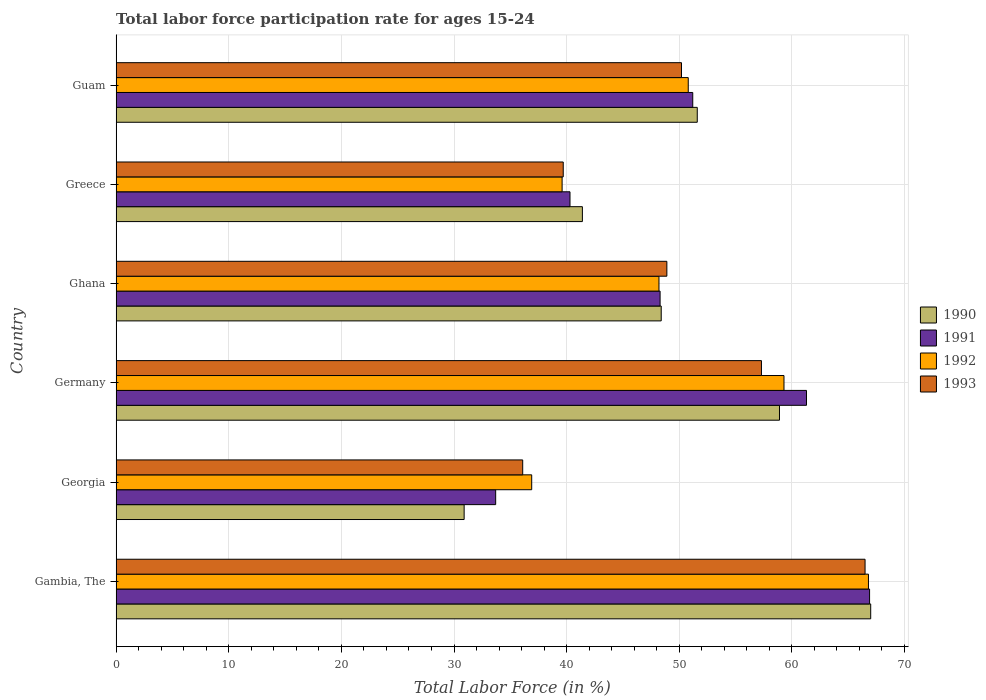How many groups of bars are there?
Offer a terse response. 6. How many bars are there on the 3rd tick from the top?
Your answer should be compact. 4. What is the label of the 2nd group of bars from the top?
Provide a succinct answer. Greece. What is the labor force participation rate in 1992 in Guam?
Your answer should be compact. 50.8. Across all countries, what is the maximum labor force participation rate in 1993?
Offer a terse response. 66.5. Across all countries, what is the minimum labor force participation rate in 1991?
Provide a short and direct response. 33.7. In which country was the labor force participation rate in 1991 maximum?
Provide a short and direct response. Gambia, The. In which country was the labor force participation rate in 1990 minimum?
Offer a terse response. Georgia. What is the total labor force participation rate in 1992 in the graph?
Offer a terse response. 301.6. What is the difference between the labor force participation rate in 1991 in Georgia and that in Germany?
Give a very brief answer. -27.6. What is the difference between the labor force participation rate in 1991 in Ghana and the labor force participation rate in 1993 in Guam?
Offer a very short reply. -1.9. What is the average labor force participation rate in 1991 per country?
Offer a very short reply. 50.28. What is the difference between the labor force participation rate in 1992 and labor force participation rate in 1990 in Guam?
Offer a very short reply. -0.8. What is the ratio of the labor force participation rate in 1991 in Georgia to that in Greece?
Offer a terse response. 0.84. Is the difference between the labor force participation rate in 1992 in Georgia and Greece greater than the difference between the labor force participation rate in 1990 in Georgia and Greece?
Keep it short and to the point. Yes. What is the difference between the highest and the second highest labor force participation rate in 1992?
Make the answer very short. 7.5. What is the difference between the highest and the lowest labor force participation rate in 1992?
Ensure brevity in your answer.  29.9. Is the sum of the labor force participation rate in 1991 in Georgia and Germany greater than the maximum labor force participation rate in 1992 across all countries?
Your response must be concise. Yes. Is it the case that in every country, the sum of the labor force participation rate in 1990 and labor force participation rate in 1992 is greater than the labor force participation rate in 1993?
Make the answer very short. Yes. Are all the bars in the graph horizontal?
Offer a very short reply. Yes. What is the difference between two consecutive major ticks on the X-axis?
Your answer should be very brief. 10. Are the values on the major ticks of X-axis written in scientific E-notation?
Ensure brevity in your answer.  No. How many legend labels are there?
Your answer should be very brief. 4. What is the title of the graph?
Provide a succinct answer. Total labor force participation rate for ages 15-24. What is the label or title of the X-axis?
Provide a succinct answer. Total Labor Force (in %). What is the label or title of the Y-axis?
Give a very brief answer. Country. What is the Total Labor Force (in %) of 1991 in Gambia, The?
Your response must be concise. 66.9. What is the Total Labor Force (in %) in 1992 in Gambia, The?
Provide a short and direct response. 66.8. What is the Total Labor Force (in %) in 1993 in Gambia, The?
Provide a succinct answer. 66.5. What is the Total Labor Force (in %) in 1990 in Georgia?
Your answer should be compact. 30.9. What is the Total Labor Force (in %) of 1991 in Georgia?
Keep it short and to the point. 33.7. What is the Total Labor Force (in %) of 1992 in Georgia?
Provide a succinct answer. 36.9. What is the Total Labor Force (in %) in 1993 in Georgia?
Ensure brevity in your answer.  36.1. What is the Total Labor Force (in %) in 1990 in Germany?
Ensure brevity in your answer.  58.9. What is the Total Labor Force (in %) in 1991 in Germany?
Ensure brevity in your answer.  61.3. What is the Total Labor Force (in %) of 1992 in Germany?
Your response must be concise. 59.3. What is the Total Labor Force (in %) of 1993 in Germany?
Your answer should be very brief. 57.3. What is the Total Labor Force (in %) in 1990 in Ghana?
Offer a terse response. 48.4. What is the Total Labor Force (in %) of 1991 in Ghana?
Offer a very short reply. 48.3. What is the Total Labor Force (in %) in 1992 in Ghana?
Make the answer very short. 48.2. What is the Total Labor Force (in %) of 1993 in Ghana?
Keep it short and to the point. 48.9. What is the Total Labor Force (in %) of 1990 in Greece?
Your answer should be very brief. 41.4. What is the Total Labor Force (in %) of 1991 in Greece?
Your answer should be compact. 40.3. What is the Total Labor Force (in %) of 1992 in Greece?
Keep it short and to the point. 39.6. What is the Total Labor Force (in %) of 1993 in Greece?
Offer a very short reply. 39.7. What is the Total Labor Force (in %) in 1990 in Guam?
Make the answer very short. 51.6. What is the Total Labor Force (in %) of 1991 in Guam?
Give a very brief answer. 51.2. What is the Total Labor Force (in %) in 1992 in Guam?
Offer a terse response. 50.8. What is the Total Labor Force (in %) in 1993 in Guam?
Provide a short and direct response. 50.2. Across all countries, what is the maximum Total Labor Force (in %) of 1990?
Offer a terse response. 67. Across all countries, what is the maximum Total Labor Force (in %) of 1991?
Offer a very short reply. 66.9. Across all countries, what is the maximum Total Labor Force (in %) of 1992?
Your answer should be very brief. 66.8. Across all countries, what is the maximum Total Labor Force (in %) of 1993?
Ensure brevity in your answer.  66.5. Across all countries, what is the minimum Total Labor Force (in %) of 1990?
Your answer should be compact. 30.9. Across all countries, what is the minimum Total Labor Force (in %) of 1991?
Provide a succinct answer. 33.7. Across all countries, what is the minimum Total Labor Force (in %) in 1992?
Make the answer very short. 36.9. Across all countries, what is the minimum Total Labor Force (in %) in 1993?
Your answer should be compact. 36.1. What is the total Total Labor Force (in %) in 1990 in the graph?
Provide a short and direct response. 298.2. What is the total Total Labor Force (in %) in 1991 in the graph?
Offer a very short reply. 301.7. What is the total Total Labor Force (in %) of 1992 in the graph?
Make the answer very short. 301.6. What is the total Total Labor Force (in %) in 1993 in the graph?
Your answer should be compact. 298.7. What is the difference between the Total Labor Force (in %) in 1990 in Gambia, The and that in Georgia?
Make the answer very short. 36.1. What is the difference between the Total Labor Force (in %) of 1991 in Gambia, The and that in Georgia?
Your answer should be compact. 33.2. What is the difference between the Total Labor Force (in %) of 1992 in Gambia, The and that in Georgia?
Your answer should be compact. 29.9. What is the difference between the Total Labor Force (in %) in 1993 in Gambia, The and that in Georgia?
Give a very brief answer. 30.4. What is the difference between the Total Labor Force (in %) of 1990 in Gambia, The and that in Ghana?
Ensure brevity in your answer.  18.6. What is the difference between the Total Labor Force (in %) in 1991 in Gambia, The and that in Ghana?
Ensure brevity in your answer.  18.6. What is the difference between the Total Labor Force (in %) in 1993 in Gambia, The and that in Ghana?
Offer a terse response. 17.6. What is the difference between the Total Labor Force (in %) in 1990 in Gambia, The and that in Greece?
Make the answer very short. 25.6. What is the difference between the Total Labor Force (in %) of 1991 in Gambia, The and that in Greece?
Ensure brevity in your answer.  26.6. What is the difference between the Total Labor Force (in %) in 1992 in Gambia, The and that in Greece?
Make the answer very short. 27.2. What is the difference between the Total Labor Force (in %) in 1993 in Gambia, The and that in Greece?
Offer a very short reply. 26.8. What is the difference between the Total Labor Force (in %) of 1992 in Gambia, The and that in Guam?
Your answer should be very brief. 16. What is the difference between the Total Labor Force (in %) in 1993 in Gambia, The and that in Guam?
Make the answer very short. 16.3. What is the difference between the Total Labor Force (in %) of 1991 in Georgia and that in Germany?
Give a very brief answer. -27.6. What is the difference between the Total Labor Force (in %) in 1992 in Georgia and that in Germany?
Ensure brevity in your answer.  -22.4. What is the difference between the Total Labor Force (in %) in 1993 in Georgia and that in Germany?
Your answer should be compact. -21.2. What is the difference between the Total Labor Force (in %) of 1990 in Georgia and that in Ghana?
Offer a terse response. -17.5. What is the difference between the Total Labor Force (in %) of 1991 in Georgia and that in Ghana?
Keep it short and to the point. -14.6. What is the difference between the Total Labor Force (in %) in 1993 in Georgia and that in Ghana?
Your answer should be very brief. -12.8. What is the difference between the Total Labor Force (in %) in 1990 in Georgia and that in Guam?
Your answer should be very brief. -20.7. What is the difference between the Total Labor Force (in %) of 1991 in Georgia and that in Guam?
Provide a succinct answer. -17.5. What is the difference between the Total Labor Force (in %) in 1993 in Georgia and that in Guam?
Give a very brief answer. -14.1. What is the difference between the Total Labor Force (in %) in 1990 in Germany and that in Ghana?
Your answer should be very brief. 10.5. What is the difference between the Total Labor Force (in %) of 1991 in Germany and that in Ghana?
Keep it short and to the point. 13. What is the difference between the Total Labor Force (in %) in 1993 in Germany and that in Ghana?
Ensure brevity in your answer.  8.4. What is the difference between the Total Labor Force (in %) of 1993 in Germany and that in Greece?
Give a very brief answer. 17.6. What is the difference between the Total Labor Force (in %) in 1990 in Germany and that in Guam?
Ensure brevity in your answer.  7.3. What is the difference between the Total Labor Force (in %) in 1991 in Germany and that in Guam?
Your answer should be compact. 10.1. What is the difference between the Total Labor Force (in %) of 1992 in Germany and that in Guam?
Provide a succinct answer. 8.5. What is the difference between the Total Labor Force (in %) in 1990 in Ghana and that in Greece?
Offer a very short reply. 7. What is the difference between the Total Labor Force (in %) of 1990 in Ghana and that in Guam?
Offer a terse response. -3.2. What is the difference between the Total Labor Force (in %) of 1991 in Ghana and that in Guam?
Your answer should be very brief. -2.9. What is the difference between the Total Labor Force (in %) of 1992 in Ghana and that in Guam?
Your answer should be compact. -2.6. What is the difference between the Total Labor Force (in %) of 1990 in Greece and that in Guam?
Provide a short and direct response. -10.2. What is the difference between the Total Labor Force (in %) in 1991 in Greece and that in Guam?
Give a very brief answer. -10.9. What is the difference between the Total Labor Force (in %) of 1992 in Greece and that in Guam?
Give a very brief answer. -11.2. What is the difference between the Total Labor Force (in %) of 1990 in Gambia, The and the Total Labor Force (in %) of 1991 in Georgia?
Offer a terse response. 33.3. What is the difference between the Total Labor Force (in %) of 1990 in Gambia, The and the Total Labor Force (in %) of 1992 in Georgia?
Provide a short and direct response. 30.1. What is the difference between the Total Labor Force (in %) in 1990 in Gambia, The and the Total Labor Force (in %) in 1993 in Georgia?
Keep it short and to the point. 30.9. What is the difference between the Total Labor Force (in %) of 1991 in Gambia, The and the Total Labor Force (in %) of 1992 in Georgia?
Your answer should be very brief. 30. What is the difference between the Total Labor Force (in %) of 1991 in Gambia, The and the Total Labor Force (in %) of 1993 in Georgia?
Offer a terse response. 30.8. What is the difference between the Total Labor Force (in %) of 1992 in Gambia, The and the Total Labor Force (in %) of 1993 in Georgia?
Your answer should be very brief. 30.7. What is the difference between the Total Labor Force (in %) in 1990 in Gambia, The and the Total Labor Force (in %) in 1991 in Germany?
Provide a succinct answer. 5.7. What is the difference between the Total Labor Force (in %) of 1991 in Gambia, The and the Total Labor Force (in %) of 1993 in Ghana?
Provide a succinct answer. 18. What is the difference between the Total Labor Force (in %) of 1990 in Gambia, The and the Total Labor Force (in %) of 1991 in Greece?
Make the answer very short. 26.7. What is the difference between the Total Labor Force (in %) of 1990 in Gambia, The and the Total Labor Force (in %) of 1992 in Greece?
Keep it short and to the point. 27.4. What is the difference between the Total Labor Force (in %) of 1990 in Gambia, The and the Total Labor Force (in %) of 1993 in Greece?
Keep it short and to the point. 27.3. What is the difference between the Total Labor Force (in %) in 1991 in Gambia, The and the Total Labor Force (in %) in 1992 in Greece?
Give a very brief answer. 27.3. What is the difference between the Total Labor Force (in %) in 1991 in Gambia, The and the Total Labor Force (in %) in 1993 in Greece?
Provide a short and direct response. 27.2. What is the difference between the Total Labor Force (in %) of 1992 in Gambia, The and the Total Labor Force (in %) of 1993 in Greece?
Offer a terse response. 27.1. What is the difference between the Total Labor Force (in %) in 1990 in Gambia, The and the Total Labor Force (in %) in 1991 in Guam?
Provide a succinct answer. 15.8. What is the difference between the Total Labor Force (in %) of 1991 in Gambia, The and the Total Labor Force (in %) of 1993 in Guam?
Provide a succinct answer. 16.7. What is the difference between the Total Labor Force (in %) of 1990 in Georgia and the Total Labor Force (in %) of 1991 in Germany?
Offer a terse response. -30.4. What is the difference between the Total Labor Force (in %) in 1990 in Georgia and the Total Labor Force (in %) in 1992 in Germany?
Your answer should be compact. -28.4. What is the difference between the Total Labor Force (in %) in 1990 in Georgia and the Total Labor Force (in %) in 1993 in Germany?
Your answer should be very brief. -26.4. What is the difference between the Total Labor Force (in %) in 1991 in Georgia and the Total Labor Force (in %) in 1992 in Germany?
Make the answer very short. -25.6. What is the difference between the Total Labor Force (in %) of 1991 in Georgia and the Total Labor Force (in %) of 1993 in Germany?
Provide a short and direct response. -23.6. What is the difference between the Total Labor Force (in %) of 1992 in Georgia and the Total Labor Force (in %) of 1993 in Germany?
Give a very brief answer. -20.4. What is the difference between the Total Labor Force (in %) in 1990 in Georgia and the Total Labor Force (in %) in 1991 in Ghana?
Provide a succinct answer. -17.4. What is the difference between the Total Labor Force (in %) in 1990 in Georgia and the Total Labor Force (in %) in 1992 in Ghana?
Your answer should be compact. -17.3. What is the difference between the Total Labor Force (in %) of 1991 in Georgia and the Total Labor Force (in %) of 1992 in Ghana?
Make the answer very short. -14.5. What is the difference between the Total Labor Force (in %) of 1991 in Georgia and the Total Labor Force (in %) of 1993 in Ghana?
Your answer should be compact. -15.2. What is the difference between the Total Labor Force (in %) in 1990 in Georgia and the Total Labor Force (in %) in 1991 in Greece?
Offer a terse response. -9.4. What is the difference between the Total Labor Force (in %) of 1990 in Georgia and the Total Labor Force (in %) of 1993 in Greece?
Make the answer very short. -8.8. What is the difference between the Total Labor Force (in %) of 1991 in Georgia and the Total Labor Force (in %) of 1992 in Greece?
Ensure brevity in your answer.  -5.9. What is the difference between the Total Labor Force (in %) of 1991 in Georgia and the Total Labor Force (in %) of 1993 in Greece?
Give a very brief answer. -6. What is the difference between the Total Labor Force (in %) in 1990 in Georgia and the Total Labor Force (in %) in 1991 in Guam?
Keep it short and to the point. -20.3. What is the difference between the Total Labor Force (in %) in 1990 in Georgia and the Total Labor Force (in %) in 1992 in Guam?
Your answer should be compact. -19.9. What is the difference between the Total Labor Force (in %) in 1990 in Georgia and the Total Labor Force (in %) in 1993 in Guam?
Your answer should be compact. -19.3. What is the difference between the Total Labor Force (in %) in 1991 in Georgia and the Total Labor Force (in %) in 1992 in Guam?
Offer a terse response. -17.1. What is the difference between the Total Labor Force (in %) of 1991 in Georgia and the Total Labor Force (in %) of 1993 in Guam?
Offer a very short reply. -16.5. What is the difference between the Total Labor Force (in %) in 1992 in Georgia and the Total Labor Force (in %) in 1993 in Guam?
Keep it short and to the point. -13.3. What is the difference between the Total Labor Force (in %) in 1990 in Germany and the Total Labor Force (in %) in 1991 in Ghana?
Provide a short and direct response. 10.6. What is the difference between the Total Labor Force (in %) in 1990 in Germany and the Total Labor Force (in %) in 1993 in Ghana?
Provide a succinct answer. 10. What is the difference between the Total Labor Force (in %) of 1991 in Germany and the Total Labor Force (in %) of 1993 in Ghana?
Your answer should be compact. 12.4. What is the difference between the Total Labor Force (in %) in 1992 in Germany and the Total Labor Force (in %) in 1993 in Ghana?
Your response must be concise. 10.4. What is the difference between the Total Labor Force (in %) of 1990 in Germany and the Total Labor Force (in %) of 1992 in Greece?
Make the answer very short. 19.3. What is the difference between the Total Labor Force (in %) in 1991 in Germany and the Total Labor Force (in %) in 1992 in Greece?
Keep it short and to the point. 21.7. What is the difference between the Total Labor Force (in %) in 1991 in Germany and the Total Labor Force (in %) in 1993 in Greece?
Offer a very short reply. 21.6. What is the difference between the Total Labor Force (in %) in 1992 in Germany and the Total Labor Force (in %) in 1993 in Greece?
Provide a short and direct response. 19.6. What is the difference between the Total Labor Force (in %) in 1990 in Germany and the Total Labor Force (in %) in 1992 in Guam?
Provide a succinct answer. 8.1. What is the difference between the Total Labor Force (in %) of 1990 in Germany and the Total Labor Force (in %) of 1993 in Guam?
Your answer should be very brief. 8.7. What is the difference between the Total Labor Force (in %) of 1992 in Germany and the Total Labor Force (in %) of 1993 in Guam?
Make the answer very short. 9.1. What is the difference between the Total Labor Force (in %) of 1990 in Ghana and the Total Labor Force (in %) of 1992 in Greece?
Offer a very short reply. 8.8. What is the difference between the Total Labor Force (in %) of 1991 in Ghana and the Total Labor Force (in %) of 1993 in Greece?
Ensure brevity in your answer.  8.6. What is the difference between the Total Labor Force (in %) in 1992 in Ghana and the Total Labor Force (in %) in 1993 in Greece?
Make the answer very short. 8.5. What is the difference between the Total Labor Force (in %) of 1990 in Ghana and the Total Labor Force (in %) of 1991 in Guam?
Ensure brevity in your answer.  -2.8. What is the difference between the Total Labor Force (in %) in 1990 in Greece and the Total Labor Force (in %) in 1992 in Guam?
Offer a terse response. -9.4. What is the difference between the Total Labor Force (in %) in 1990 in Greece and the Total Labor Force (in %) in 1993 in Guam?
Keep it short and to the point. -8.8. What is the difference between the Total Labor Force (in %) in 1991 in Greece and the Total Labor Force (in %) in 1992 in Guam?
Provide a succinct answer. -10.5. What is the average Total Labor Force (in %) in 1990 per country?
Offer a very short reply. 49.7. What is the average Total Labor Force (in %) of 1991 per country?
Your answer should be very brief. 50.28. What is the average Total Labor Force (in %) in 1992 per country?
Offer a terse response. 50.27. What is the average Total Labor Force (in %) of 1993 per country?
Your answer should be very brief. 49.78. What is the difference between the Total Labor Force (in %) of 1990 and Total Labor Force (in %) of 1991 in Gambia, The?
Give a very brief answer. 0.1. What is the difference between the Total Labor Force (in %) in 1990 and Total Labor Force (in %) in 1993 in Gambia, The?
Your answer should be very brief. 0.5. What is the difference between the Total Labor Force (in %) in 1991 and Total Labor Force (in %) in 1993 in Gambia, The?
Offer a terse response. 0.4. What is the difference between the Total Labor Force (in %) of 1990 and Total Labor Force (in %) of 1993 in Georgia?
Provide a short and direct response. -5.2. What is the difference between the Total Labor Force (in %) of 1991 and Total Labor Force (in %) of 1992 in Georgia?
Provide a short and direct response. -3.2. What is the difference between the Total Labor Force (in %) in 1991 and Total Labor Force (in %) in 1993 in Georgia?
Keep it short and to the point. -2.4. What is the difference between the Total Labor Force (in %) of 1992 and Total Labor Force (in %) of 1993 in Georgia?
Keep it short and to the point. 0.8. What is the difference between the Total Labor Force (in %) in 1991 and Total Labor Force (in %) in 1992 in Germany?
Offer a very short reply. 2. What is the difference between the Total Labor Force (in %) in 1992 and Total Labor Force (in %) in 1993 in Ghana?
Your response must be concise. -0.7. What is the difference between the Total Labor Force (in %) in 1990 and Total Labor Force (in %) in 1991 in Greece?
Your answer should be compact. 1.1. What is the difference between the Total Labor Force (in %) in 1990 and Total Labor Force (in %) in 1993 in Greece?
Make the answer very short. 1.7. What is the difference between the Total Labor Force (in %) of 1991 and Total Labor Force (in %) of 1992 in Greece?
Your response must be concise. 0.7. What is the difference between the Total Labor Force (in %) in 1990 and Total Labor Force (in %) in 1991 in Guam?
Your response must be concise. 0.4. What is the difference between the Total Labor Force (in %) in 1990 and Total Labor Force (in %) in 1992 in Guam?
Keep it short and to the point. 0.8. What is the difference between the Total Labor Force (in %) of 1990 and Total Labor Force (in %) of 1993 in Guam?
Provide a succinct answer. 1.4. What is the ratio of the Total Labor Force (in %) in 1990 in Gambia, The to that in Georgia?
Your answer should be compact. 2.17. What is the ratio of the Total Labor Force (in %) in 1991 in Gambia, The to that in Georgia?
Offer a very short reply. 1.99. What is the ratio of the Total Labor Force (in %) of 1992 in Gambia, The to that in Georgia?
Offer a very short reply. 1.81. What is the ratio of the Total Labor Force (in %) of 1993 in Gambia, The to that in Georgia?
Make the answer very short. 1.84. What is the ratio of the Total Labor Force (in %) of 1990 in Gambia, The to that in Germany?
Provide a short and direct response. 1.14. What is the ratio of the Total Labor Force (in %) in 1991 in Gambia, The to that in Germany?
Your answer should be compact. 1.09. What is the ratio of the Total Labor Force (in %) in 1992 in Gambia, The to that in Germany?
Your answer should be very brief. 1.13. What is the ratio of the Total Labor Force (in %) of 1993 in Gambia, The to that in Germany?
Give a very brief answer. 1.16. What is the ratio of the Total Labor Force (in %) of 1990 in Gambia, The to that in Ghana?
Ensure brevity in your answer.  1.38. What is the ratio of the Total Labor Force (in %) of 1991 in Gambia, The to that in Ghana?
Offer a terse response. 1.39. What is the ratio of the Total Labor Force (in %) in 1992 in Gambia, The to that in Ghana?
Provide a succinct answer. 1.39. What is the ratio of the Total Labor Force (in %) in 1993 in Gambia, The to that in Ghana?
Your answer should be very brief. 1.36. What is the ratio of the Total Labor Force (in %) in 1990 in Gambia, The to that in Greece?
Provide a succinct answer. 1.62. What is the ratio of the Total Labor Force (in %) of 1991 in Gambia, The to that in Greece?
Your answer should be compact. 1.66. What is the ratio of the Total Labor Force (in %) in 1992 in Gambia, The to that in Greece?
Offer a terse response. 1.69. What is the ratio of the Total Labor Force (in %) in 1993 in Gambia, The to that in Greece?
Keep it short and to the point. 1.68. What is the ratio of the Total Labor Force (in %) of 1990 in Gambia, The to that in Guam?
Keep it short and to the point. 1.3. What is the ratio of the Total Labor Force (in %) in 1991 in Gambia, The to that in Guam?
Provide a succinct answer. 1.31. What is the ratio of the Total Labor Force (in %) of 1992 in Gambia, The to that in Guam?
Provide a succinct answer. 1.31. What is the ratio of the Total Labor Force (in %) of 1993 in Gambia, The to that in Guam?
Provide a short and direct response. 1.32. What is the ratio of the Total Labor Force (in %) in 1990 in Georgia to that in Germany?
Offer a very short reply. 0.52. What is the ratio of the Total Labor Force (in %) of 1991 in Georgia to that in Germany?
Provide a succinct answer. 0.55. What is the ratio of the Total Labor Force (in %) in 1992 in Georgia to that in Germany?
Provide a short and direct response. 0.62. What is the ratio of the Total Labor Force (in %) in 1993 in Georgia to that in Germany?
Provide a short and direct response. 0.63. What is the ratio of the Total Labor Force (in %) in 1990 in Georgia to that in Ghana?
Keep it short and to the point. 0.64. What is the ratio of the Total Labor Force (in %) in 1991 in Georgia to that in Ghana?
Offer a terse response. 0.7. What is the ratio of the Total Labor Force (in %) in 1992 in Georgia to that in Ghana?
Provide a succinct answer. 0.77. What is the ratio of the Total Labor Force (in %) of 1993 in Georgia to that in Ghana?
Ensure brevity in your answer.  0.74. What is the ratio of the Total Labor Force (in %) in 1990 in Georgia to that in Greece?
Provide a short and direct response. 0.75. What is the ratio of the Total Labor Force (in %) in 1991 in Georgia to that in Greece?
Offer a terse response. 0.84. What is the ratio of the Total Labor Force (in %) of 1992 in Georgia to that in Greece?
Your answer should be very brief. 0.93. What is the ratio of the Total Labor Force (in %) of 1993 in Georgia to that in Greece?
Make the answer very short. 0.91. What is the ratio of the Total Labor Force (in %) in 1990 in Georgia to that in Guam?
Keep it short and to the point. 0.6. What is the ratio of the Total Labor Force (in %) in 1991 in Georgia to that in Guam?
Ensure brevity in your answer.  0.66. What is the ratio of the Total Labor Force (in %) of 1992 in Georgia to that in Guam?
Provide a succinct answer. 0.73. What is the ratio of the Total Labor Force (in %) in 1993 in Georgia to that in Guam?
Your answer should be compact. 0.72. What is the ratio of the Total Labor Force (in %) in 1990 in Germany to that in Ghana?
Your response must be concise. 1.22. What is the ratio of the Total Labor Force (in %) in 1991 in Germany to that in Ghana?
Offer a very short reply. 1.27. What is the ratio of the Total Labor Force (in %) of 1992 in Germany to that in Ghana?
Ensure brevity in your answer.  1.23. What is the ratio of the Total Labor Force (in %) of 1993 in Germany to that in Ghana?
Provide a succinct answer. 1.17. What is the ratio of the Total Labor Force (in %) of 1990 in Germany to that in Greece?
Ensure brevity in your answer.  1.42. What is the ratio of the Total Labor Force (in %) in 1991 in Germany to that in Greece?
Keep it short and to the point. 1.52. What is the ratio of the Total Labor Force (in %) of 1992 in Germany to that in Greece?
Give a very brief answer. 1.5. What is the ratio of the Total Labor Force (in %) in 1993 in Germany to that in Greece?
Offer a terse response. 1.44. What is the ratio of the Total Labor Force (in %) of 1990 in Germany to that in Guam?
Make the answer very short. 1.14. What is the ratio of the Total Labor Force (in %) of 1991 in Germany to that in Guam?
Give a very brief answer. 1.2. What is the ratio of the Total Labor Force (in %) of 1992 in Germany to that in Guam?
Provide a succinct answer. 1.17. What is the ratio of the Total Labor Force (in %) of 1993 in Germany to that in Guam?
Provide a succinct answer. 1.14. What is the ratio of the Total Labor Force (in %) in 1990 in Ghana to that in Greece?
Your answer should be very brief. 1.17. What is the ratio of the Total Labor Force (in %) in 1991 in Ghana to that in Greece?
Keep it short and to the point. 1.2. What is the ratio of the Total Labor Force (in %) in 1992 in Ghana to that in Greece?
Offer a terse response. 1.22. What is the ratio of the Total Labor Force (in %) in 1993 in Ghana to that in Greece?
Provide a short and direct response. 1.23. What is the ratio of the Total Labor Force (in %) in 1990 in Ghana to that in Guam?
Make the answer very short. 0.94. What is the ratio of the Total Labor Force (in %) in 1991 in Ghana to that in Guam?
Give a very brief answer. 0.94. What is the ratio of the Total Labor Force (in %) of 1992 in Ghana to that in Guam?
Make the answer very short. 0.95. What is the ratio of the Total Labor Force (in %) of 1993 in Ghana to that in Guam?
Ensure brevity in your answer.  0.97. What is the ratio of the Total Labor Force (in %) of 1990 in Greece to that in Guam?
Keep it short and to the point. 0.8. What is the ratio of the Total Labor Force (in %) in 1991 in Greece to that in Guam?
Your answer should be very brief. 0.79. What is the ratio of the Total Labor Force (in %) in 1992 in Greece to that in Guam?
Provide a short and direct response. 0.78. What is the ratio of the Total Labor Force (in %) in 1993 in Greece to that in Guam?
Offer a very short reply. 0.79. What is the difference between the highest and the second highest Total Labor Force (in %) in 1991?
Your response must be concise. 5.6. What is the difference between the highest and the second highest Total Labor Force (in %) of 1993?
Offer a terse response. 9.2. What is the difference between the highest and the lowest Total Labor Force (in %) in 1990?
Offer a terse response. 36.1. What is the difference between the highest and the lowest Total Labor Force (in %) in 1991?
Provide a short and direct response. 33.2. What is the difference between the highest and the lowest Total Labor Force (in %) in 1992?
Make the answer very short. 29.9. What is the difference between the highest and the lowest Total Labor Force (in %) of 1993?
Make the answer very short. 30.4. 